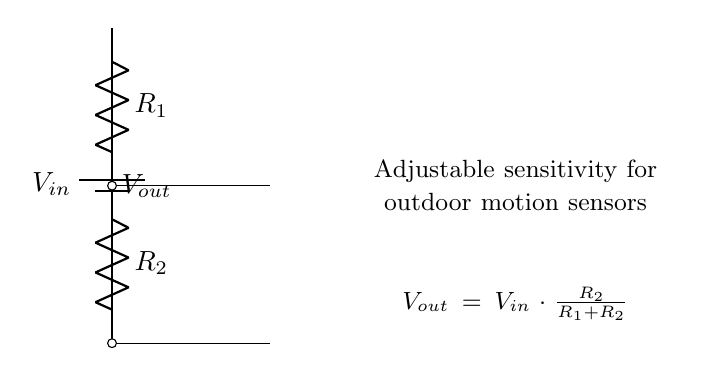What are the resistors in the circuit? There are two resistors present in the circuit labeled as R1 and R2.
Answer: R1, R2 What is the input voltage denoted as? The input voltage is represented as Vin in the circuit diagram.
Answer: Vin What does Vout depend on? Vout depends on the values of R1 and R2 according to the voltage divider formula, which states that Vout equals Vin multiplied by the ratio of R2 to the total resistance R1 plus R2.
Answer: R1 and R2 What is the formula for Vout? The formula for Vout is given as Vout equals Vin times R2 divided by the sum of R1 and R2, as indicated in the circuit diagram.
Answer: Vout = Vin * (R2 / (R1 + R2)) What happens to Vout if R1 increases? If R1 increases, the output voltage Vout decreases because a larger R1 increases the overall resistance in the denominator of the voltage divider formula.
Answer: Vout decreases What is the function of this voltage divider setup? The purpose of this voltage divider is to adjust the sensitivity of outdoor motion sensors by varying the output voltage Vout based on the resistor values.
Answer: Adjustable sensitivity 